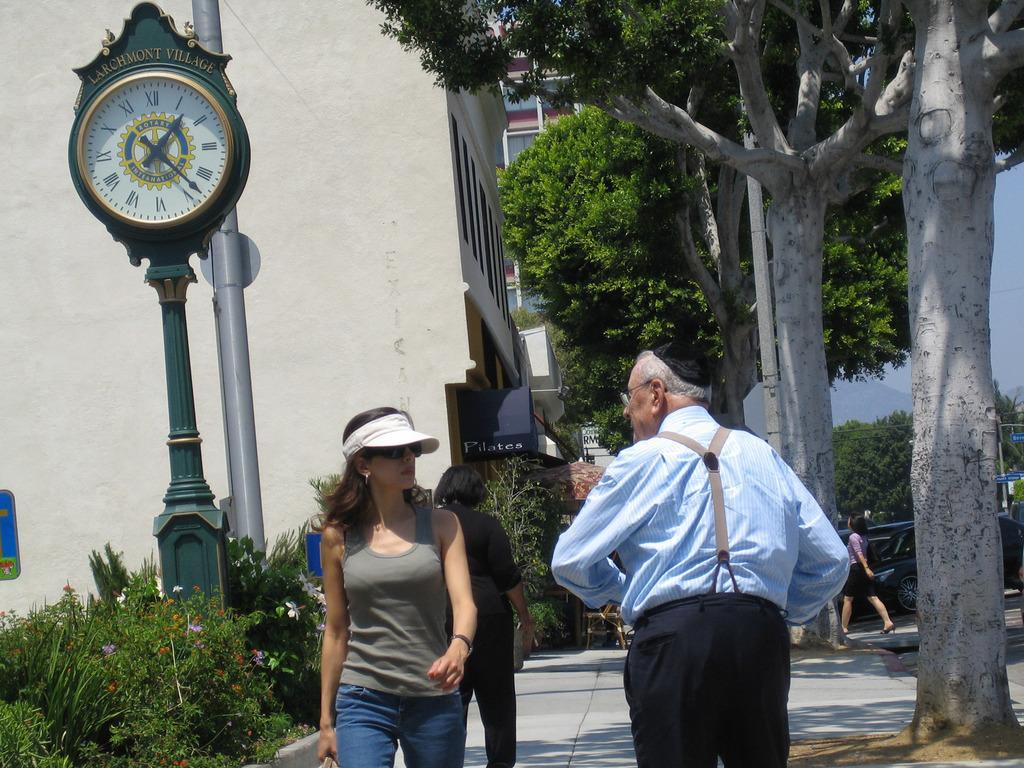Describe this image in one or two sentences. This is an outside view. Hear I can see few people are walking on the road. In the foreground a woman and a man are looking at each other. In the background, I can see some trees and buildings. On the left side there is a clock pole and some plants. 